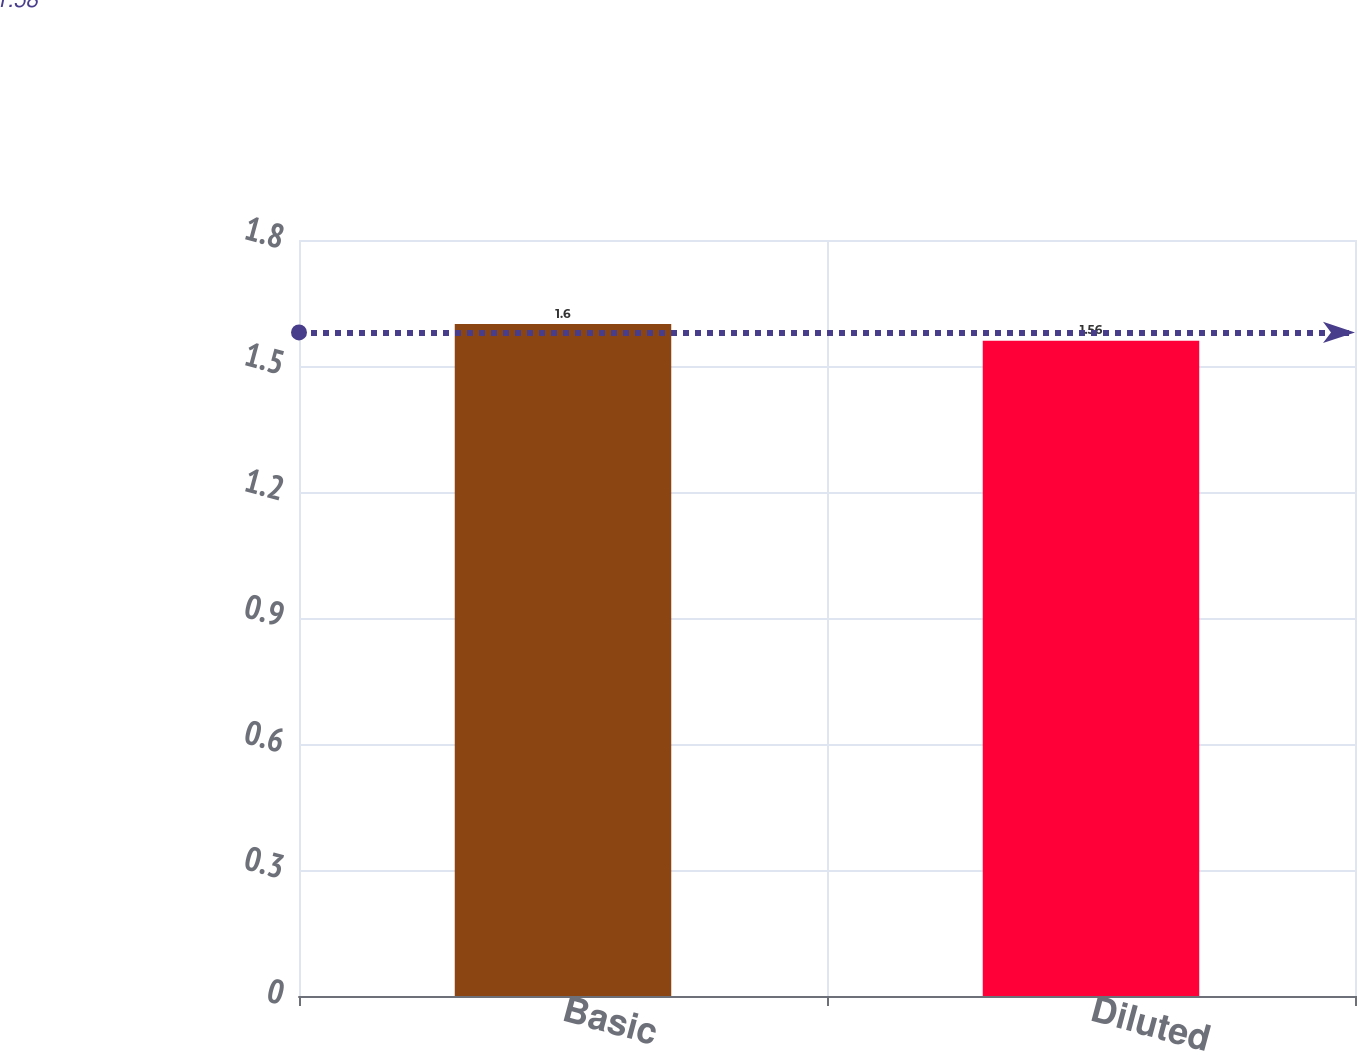Convert chart. <chart><loc_0><loc_0><loc_500><loc_500><bar_chart><fcel>Basic<fcel>Diluted<nl><fcel>1.6<fcel>1.56<nl></chart> 